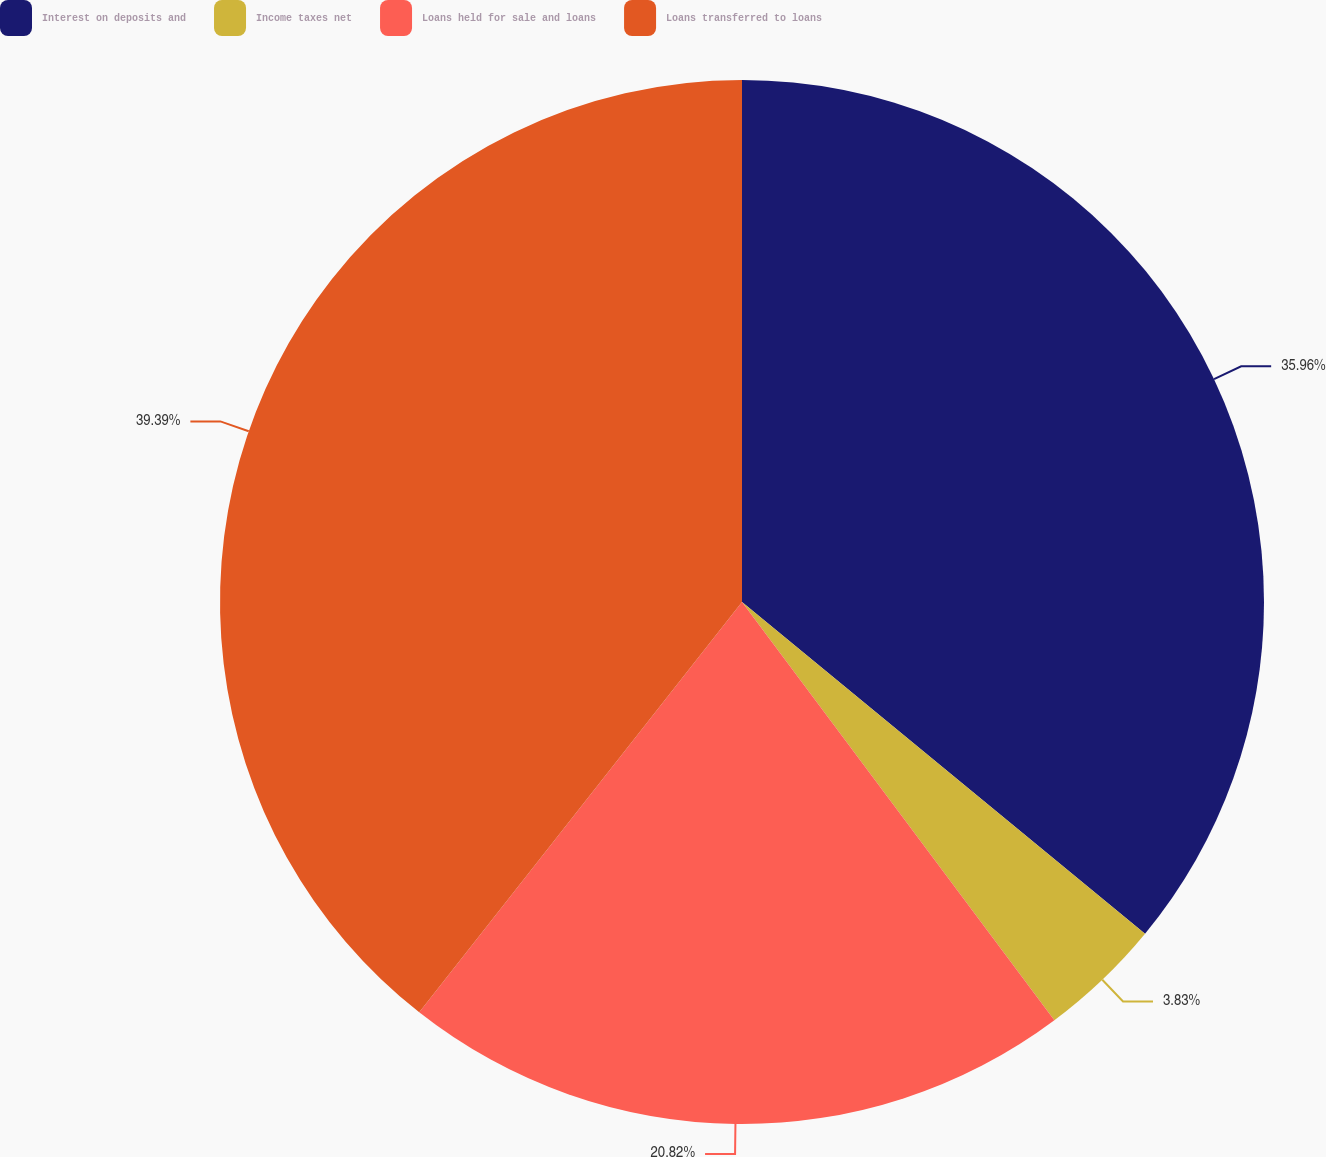Convert chart. <chart><loc_0><loc_0><loc_500><loc_500><pie_chart><fcel>Interest on deposits and<fcel>Income taxes net<fcel>Loans held for sale and loans<fcel>Loans transferred to loans<nl><fcel>35.96%<fcel>3.83%<fcel>20.82%<fcel>39.39%<nl></chart> 